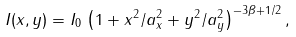Convert formula to latex. <formula><loc_0><loc_0><loc_500><loc_500>I ( x , y ) = I _ { 0 } \, \left ( 1 + x ^ { 2 } / a _ { x } ^ { 2 } + y ^ { 2 } / a _ { y } ^ { 2 } \right ) ^ { - 3 \beta + 1 / 2 } ,</formula> 